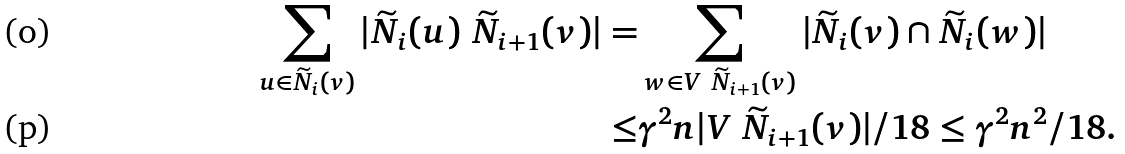Convert formula to latex. <formula><loc_0><loc_0><loc_500><loc_500>\sum _ { u \in \widetilde { N } _ { i } ( v ) } | \widetilde { N } _ { i } ( u ) \ \widetilde { N } _ { i + 1 } ( v ) | = & \sum _ { w \in V \ \widetilde { N } _ { i + 1 } ( v ) } | \widetilde { N } _ { i } ( v ) \cap \widetilde { N } _ { i } ( w ) | \\ \leq & { \gamma ^ { 2 } n } | V \ \widetilde { N } _ { i + 1 } ( v ) | / 1 8 \leq \gamma ^ { 2 } n ^ { 2 } / 1 8 .</formula> 